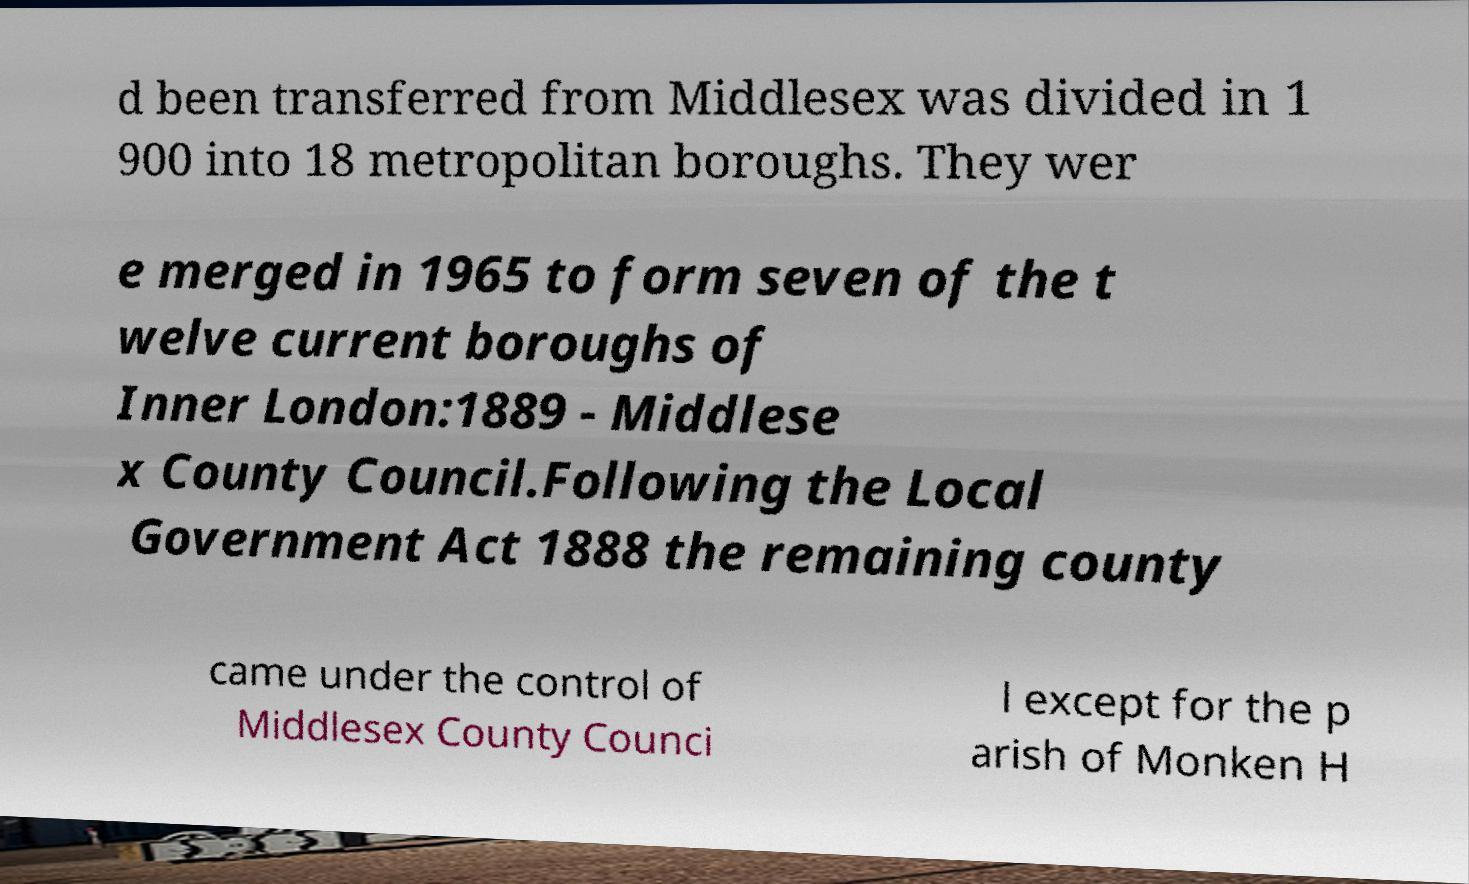Could you extract and type out the text from this image? d been transferred from Middlesex was divided in 1 900 into 18 metropolitan boroughs. They wer e merged in 1965 to form seven of the t welve current boroughs of Inner London:1889 - Middlese x County Council.Following the Local Government Act 1888 the remaining county came under the control of Middlesex County Counci l except for the p arish of Monken H 